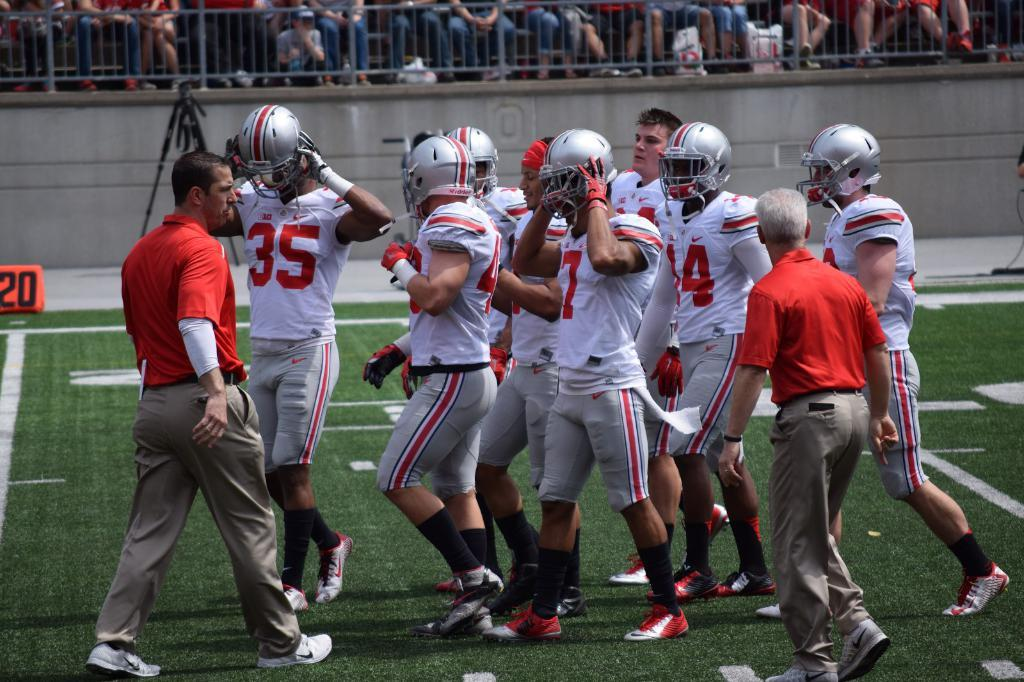What are the people in the image doing? The people in the image are walking on the ground. What can be seen near the people walking? There is a railing visible in the image. Who is behind the railing in the image? There are spectators behind the railing in the image. Where can the shop be found in the image? There is no shop present in the image. How many trees are visible in the image? There are no trees visible in the image. 